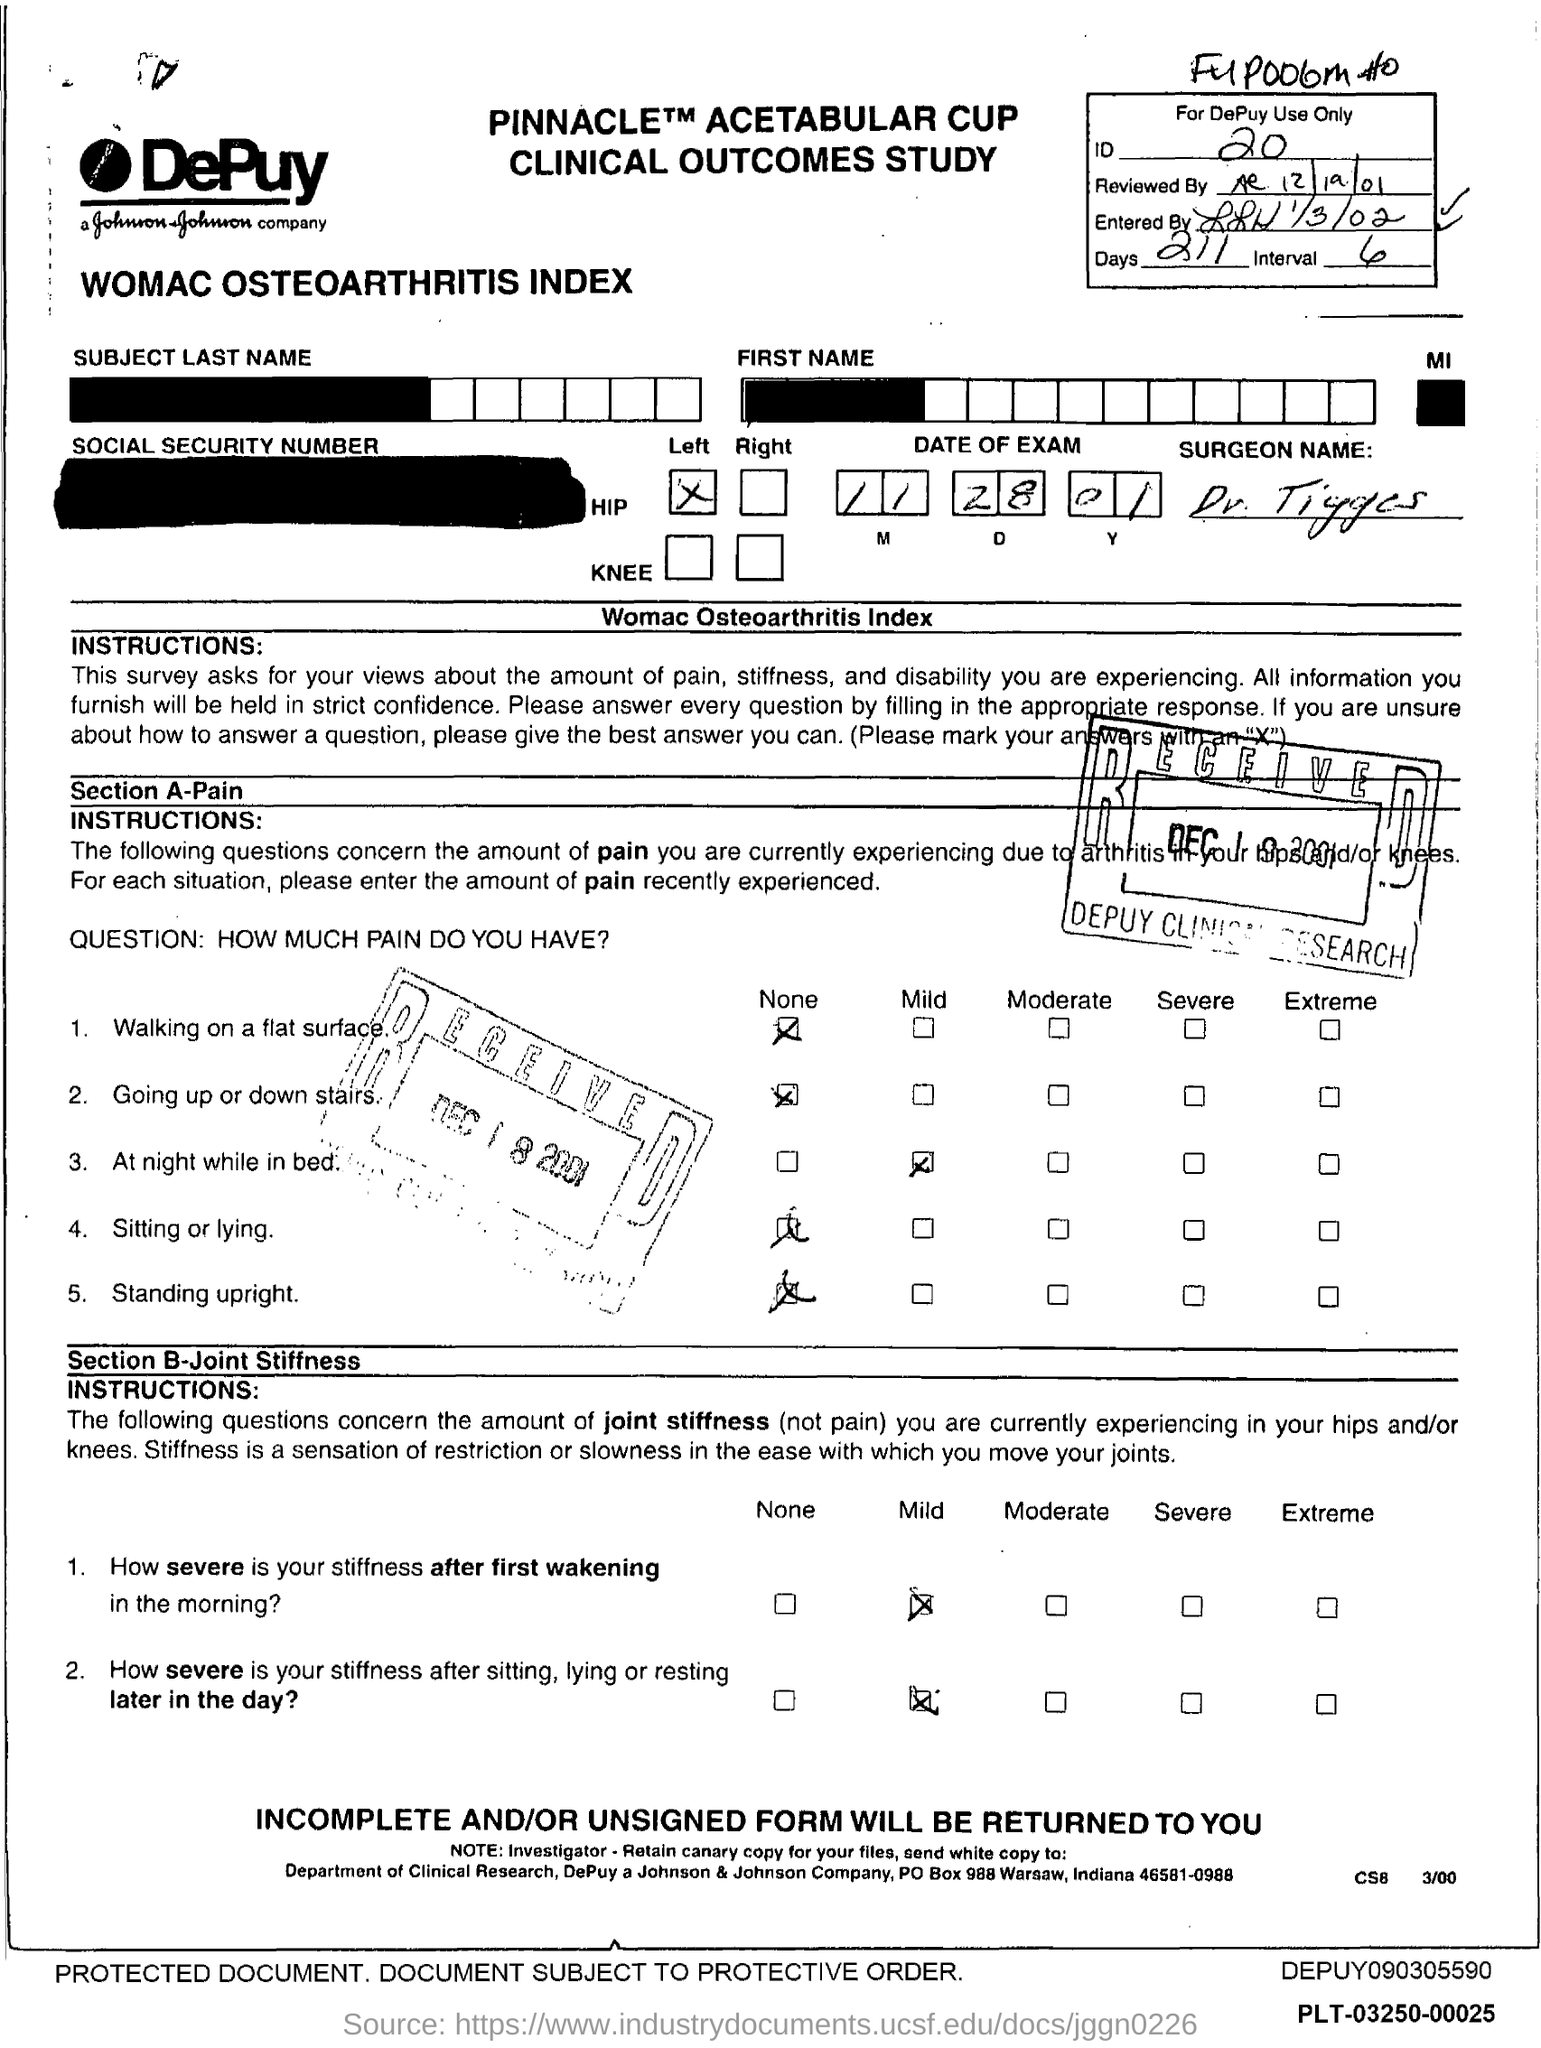What is the ID?
Ensure brevity in your answer.  20. What are the days?
Keep it short and to the point. 211. What is the Interval?
Provide a succinct answer. 6. What is Date of exam?
Keep it short and to the point. 11-28-01. 